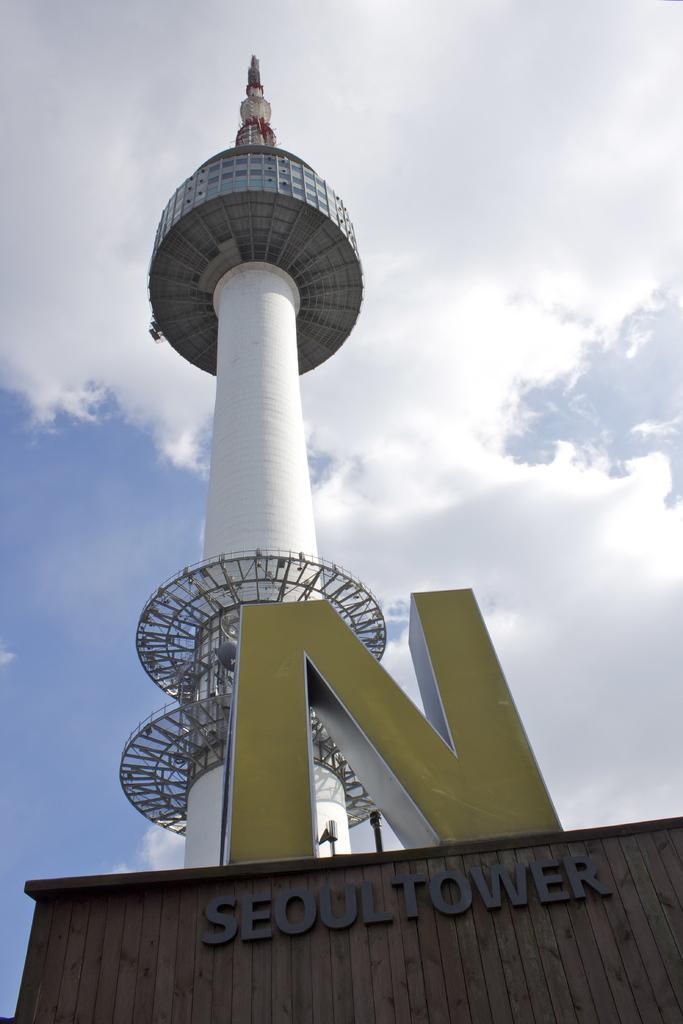Could you give a brief overview of what you see in this image? In this picture I can see a tower and I can see text on the wall and I can see a blue cloudy sky. 